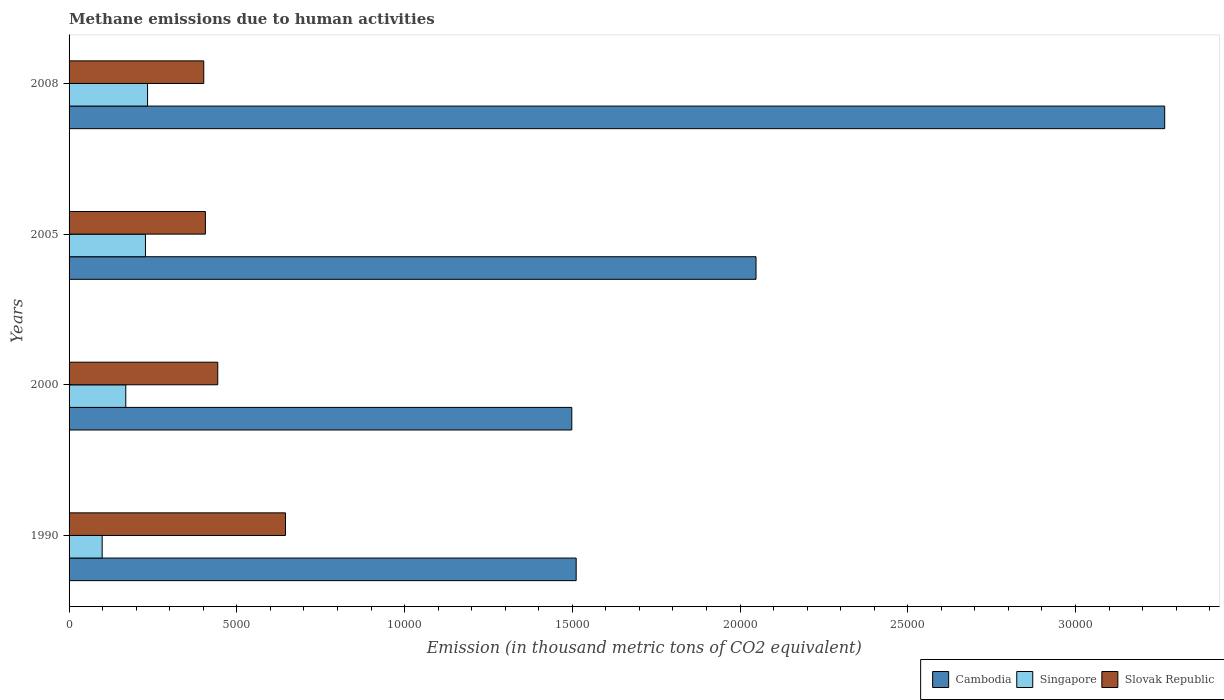How many different coloured bars are there?
Give a very brief answer. 3. How many groups of bars are there?
Provide a succinct answer. 4. Are the number of bars per tick equal to the number of legend labels?
Offer a terse response. Yes. In how many cases, is the number of bars for a given year not equal to the number of legend labels?
Offer a terse response. 0. What is the amount of methane emitted in Cambodia in 1990?
Give a very brief answer. 1.51e+04. Across all years, what is the maximum amount of methane emitted in Cambodia?
Make the answer very short. 3.27e+04. Across all years, what is the minimum amount of methane emitted in Singapore?
Make the answer very short. 986.7. In which year was the amount of methane emitted in Cambodia maximum?
Your answer should be very brief. 2008. In which year was the amount of methane emitted in Slovak Republic minimum?
Provide a succinct answer. 2008. What is the total amount of methane emitted in Cambodia in the graph?
Provide a short and direct response. 8.32e+04. What is the difference between the amount of methane emitted in Singapore in 2000 and that in 2008?
Provide a short and direct response. -649.1. What is the difference between the amount of methane emitted in Cambodia in 1990 and the amount of methane emitted in Singapore in 2005?
Keep it short and to the point. 1.28e+04. What is the average amount of methane emitted in Singapore per year?
Offer a terse response. 1823.45. In the year 1990, what is the difference between the amount of methane emitted in Slovak Republic and amount of methane emitted in Singapore?
Your answer should be very brief. 5464.7. What is the ratio of the amount of methane emitted in Cambodia in 2000 to that in 2008?
Give a very brief answer. 0.46. Is the amount of methane emitted in Singapore in 2000 less than that in 2008?
Provide a short and direct response. Yes. What is the difference between the highest and the second highest amount of methane emitted in Slovak Republic?
Your answer should be very brief. 2019.1. What is the difference between the highest and the lowest amount of methane emitted in Cambodia?
Give a very brief answer. 1.77e+04. What does the 3rd bar from the top in 2005 represents?
Offer a terse response. Cambodia. What does the 3rd bar from the bottom in 2008 represents?
Keep it short and to the point. Slovak Republic. How many years are there in the graph?
Your answer should be very brief. 4. Does the graph contain grids?
Offer a very short reply. No. What is the title of the graph?
Keep it short and to the point. Methane emissions due to human activities. What is the label or title of the X-axis?
Provide a succinct answer. Emission (in thousand metric tons of CO2 equivalent). What is the label or title of the Y-axis?
Give a very brief answer. Years. What is the Emission (in thousand metric tons of CO2 equivalent) in Cambodia in 1990?
Keep it short and to the point. 1.51e+04. What is the Emission (in thousand metric tons of CO2 equivalent) of Singapore in 1990?
Make the answer very short. 986.7. What is the Emission (in thousand metric tons of CO2 equivalent) in Slovak Republic in 1990?
Your answer should be compact. 6451.4. What is the Emission (in thousand metric tons of CO2 equivalent) of Cambodia in 2000?
Provide a succinct answer. 1.50e+04. What is the Emission (in thousand metric tons of CO2 equivalent) in Singapore in 2000?
Your answer should be compact. 1690.6. What is the Emission (in thousand metric tons of CO2 equivalent) of Slovak Republic in 2000?
Your answer should be very brief. 4432.3. What is the Emission (in thousand metric tons of CO2 equivalent) in Cambodia in 2005?
Provide a succinct answer. 2.05e+04. What is the Emission (in thousand metric tons of CO2 equivalent) in Singapore in 2005?
Provide a short and direct response. 2276.8. What is the Emission (in thousand metric tons of CO2 equivalent) in Slovak Republic in 2005?
Make the answer very short. 4063.5. What is the Emission (in thousand metric tons of CO2 equivalent) of Cambodia in 2008?
Your answer should be very brief. 3.27e+04. What is the Emission (in thousand metric tons of CO2 equivalent) of Singapore in 2008?
Ensure brevity in your answer.  2339.7. What is the Emission (in thousand metric tons of CO2 equivalent) in Slovak Republic in 2008?
Give a very brief answer. 4014.6. Across all years, what is the maximum Emission (in thousand metric tons of CO2 equivalent) of Cambodia?
Provide a short and direct response. 3.27e+04. Across all years, what is the maximum Emission (in thousand metric tons of CO2 equivalent) of Singapore?
Give a very brief answer. 2339.7. Across all years, what is the maximum Emission (in thousand metric tons of CO2 equivalent) in Slovak Republic?
Your answer should be very brief. 6451.4. Across all years, what is the minimum Emission (in thousand metric tons of CO2 equivalent) in Cambodia?
Provide a short and direct response. 1.50e+04. Across all years, what is the minimum Emission (in thousand metric tons of CO2 equivalent) in Singapore?
Give a very brief answer. 986.7. Across all years, what is the minimum Emission (in thousand metric tons of CO2 equivalent) in Slovak Republic?
Your response must be concise. 4014.6. What is the total Emission (in thousand metric tons of CO2 equivalent) of Cambodia in the graph?
Offer a terse response. 8.32e+04. What is the total Emission (in thousand metric tons of CO2 equivalent) in Singapore in the graph?
Ensure brevity in your answer.  7293.8. What is the total Emission (in thousand metric tons of CO2 equivalent) in Slovak Republic in the graph?
Make the answer very short. 1.90e+04. What is the difference between the Emission (in thousand metric tons of CO2 equivalent) of Cambodia in 1990 and that in 2000?
Provide a short and direct response. 130.8. What is the difference between the Emission (in thousand metric tons of CO2 equivalent) of Singapore in 1990 and that in 2000?
Ensure brevity in your answer.  -703.9. What is the difference between the Emission (in thousand metric tons of CO2 equivalent) in Slovak Republic in 1990 and that in 2000?
Keep it short and to the point. 2019.1. What is the difference between the Emission (in thousand metric tons of CO2 equivalent) of Cambodia in 1990 and that in 2005?
Offer a very short reply. -5361.1. What is the difference between the Emission (in thousand metric tons of CO2 equivalent) of Singapore in 1990 and that in 2005?
Your response must be concise. -1290.1. What is the difference between the Emission (in thousand metric tons of CO2 equivalent) of Slovak Republic in 1990 and that in 2005?
Make the answer very short. 2387.9. What is the difference between the Emission (in thousand metric tons of CO2 equivalent) of Cambodia in 1990 and that in 2008?
Provide a succinct answer. -1.75e+04. What is the difference between the Emission (in thousand metric tons of CO2 equivalent) in Singapore in 1990 and that in 2008?
Offer a very short reply. -1353. What is the difference between the Emission (in thousand metric tons of CO2 equivalent) in Slovak Republic in 1990 and that in 2008?
Your answer should be compact. 2436.8. What is the difference between the Emission (in thousand metric tons of CO2 equivalent) of Cambodia in 2000 and that in 2005?
Keep it short and to the point. -5491.9. What is the difference between the Emission (in thousand metric tons of CO2 equivalent) in Singapore in 2000 and that in 2005?
Provide a short and direct response. -586.2. What is the difference between the Emission (in thousand metric tons of CO2 equivalent) in Slovak Republic in 2000 and that in 2005?
Ensure brevity in your answer.  368.8. What is the difference between the Emission (in thousand metric tons of CO2 equivalent) of Cambodia in 2000 and that in 2008?
Keep it short and to the point. -1.77e+04. What is the difference between the Emission (in thousand metric tons of CO2 equivalent) in Singapore in 2000 and that in 2008?
Your response must be concise. -649.1. What is the difference between the Emission (in thousand metric tons of CO2 equivalent) in Slovak Republic in 2000 and that in 2008?
Your answer should be compact. 417.7. What is the difference between the Emission (in thousand metric tons of CO2 equivalent) of Cambodia in 2005 and that in 2008?
Make the answer very short. -1.22e+04. What is the difference between the Emission (in thousand metric tons of CO2 equivalent) of Singapore in 2005 and that in 2008?
Your response must be concise. -62.9. What is the difference between the Emission (in thousand metric tons of CO2 equivalent) in Slovak Republic in 2005 and that in 2008?
Give a very brief answer. 48.9. What is the difference between the Emission (in thousand metric tons of CO2 equivalent) of Cambodia in 1990 and the Emission (in thousand metric tons of CO2 equivalent) of Singapore in 2000?
Keep it short and to the point. 1.34e+04. What is the difference between the Emission (in thousand metric tons of CO2 equivalent) in Cambodia in 1990 and the Emission (in thousand metric tons of CO2 equivalent) in Slovak Republic in 2000?
Give a very brief answer. 1.07e+04. What is the difference between the Emission (in thousand metric tons of CO2 equivalent) of Singapore in 1990 and the Emission (in thousand metric tons of CO2 equivalent) of Slovak Republic in 2000?
Make the answer very short. -3445.6. What is the difference between the Emission (in thousand metric tons of CO2 equivalent) in Cambodia in 1990 and the Emission (in thousand metric tons of CO2 equivalent) in Singapore in 2005?
Keep it short and to the point. 1.28e+04. What is the difference between the Emission (in thousand metric tons of CO2 equivalent) of Cambodia in 1990 and the Emission (in thousand metric tons of CO2 equivalent) of Slovak Republic in 2005?
Your answer should be very brief. 1.11e+04. What is the difference between the Emission (in thousand metric tons of CO2 equivalent) of Singapore in 1990 and the Emission (in thousand metric tons of CO2 equivalent) of Slovak Republic in 2005?
Your response must be concise. -3076.8. What is the difference between the Emission (in thousand metric tons of CO2 equivalent) in Cambodia in 1990 and the Emission (in thousand metric tons of CO2 equivalent) in Singapore in 2008?
Keep it short and to the point. 1.28e+04. What is the difference between the Emission (in thousand metric tons of CO2 equivalent) of Cambodia in 1990 and the Emission (in thousand metric tons of CO2 equivalent) of Slovak Republic in 2008?
Offer a terse response. 1.11e+04. What is the difference between the Emission (in thousand metric tons of CO2 equivalent) of Singapore in 1990 and the Emission (in thousand metric tons of CO2 equivalent) of Slovak Republic in 2008?
Ensure brevity in your answer.  -3027.9. What is the difference between the Emission (in thousand metric tons of CO2 equivalent) in Cambodia in 2000 and the Emission (in thousand metric tons of CO2 equivalent) in Singapore in 2005?
Keep it short and to the point. 1.27e+04. What is the difference between the Emission (in thousand metric tons of CO2 equivalent) of Cambodia in 2000 and the Emission (in thousand metric tons of CO2 equivalent) of Slovak Republic in 2005?
Your answer should be very brief. 1.09e+04. What is the difference between the Emission (in thousand metric tons of CO2 equivalent) in Singapore in 2000 and the Emission (in thousand metric tons of CO2 equivalent) in Slovak Republic in 2005?
Ensure brevity in your answer.  -2372.9. What is the difference between the Emission (in thousand metric tons of CO2 equivalent) in Cambodia in 2000 and the Emission (in thousand metric tons of CO2 equivalent) in Singapore in 2008?
Provide a succinct answer. 1.26e+04. What is the difference between the Emission (in thousand metric tons of CO2 equivalent) of Cambodia in 2000 and the Emission (in thousand metric tons of CO2 equivalent) of Slovak Republic in 2008?
Provide a short and direct response. 1.10e+04. What is the difference between the Emission (in thousand metric tons of CO2 equivalent) of Singapore in 2000 and the Emission (in thousand metric tons of CO2 equivalent) of Slovak Republic in 2008?
Make the answer very short. -2324. What is the difference between the Emission (in thousand metric tons of CO2 equivalent) in Cambodia in 2005 and the Emission (in thousand metric tons of CO2 equivalent) in Singapore in 2008?
Ensure brevity in your answer.  1.81e+04. What is the difference between the Emission (in thousand metric tons of CO2 equivalent) of Cambodia in 2005 and the Emission (in thousand metric tons of CO2 equivalent) of Slovak Republic in 2008?
Keep it short and to the point. 1.65e+04. What is the difference between the Emission (in thousand metric tons of CO2 equivalent) of Singapore in 2005 and the Emission (in thousand metric tons of CO2 equivalent) of Slovak Republic in 2008?
Keep it short and to the point. -1737.8. What is the average Emission (in thousand metric tons of CO2 equivalent) in Cambodia per year?
Provide a succinct answer. 2.08e+04. What is the average Emission (in thousand metric tons of CO2 equivalent) in Singapore per year?
Offer a terse response. 1823.45. What is the average Emission (in thousand metric tons of CO2 equivalent) of Slovak Republic per year?
Offer a terse response. 4740.45. In the year 1990, what is the difference between the Emission (in thousand metric tons of CO2 equivalent) in Cambodia and Emission (in thousand metric tons of CO2 equivalent) in Singapore?
Give a very brief answer. 1.41e+04. In the year 1990, what is the difference between the Emission (in thousand metric tons of CO2 equivalent) of Cambodia and Emission (in thousand metric tons of CO2 equivalent) of Slovak Republic?
Keep it short and to the point. 8664.3. In the year 1990, what is the difference between the Emission (in thousand metric tons of CO2 equivalent) in Singapore and Emission (in thousand metric tons of CO2 equivalent) in Slovak Republic?
Provide a short and direct response. -5464.7. In the year 2000, what is the difference between the Emission (in thousand metric tons of CO2 equivalent) of Cambodia and Emission (in thousand metric tons of CO2 equivalent) of Singapore?
Your answer should be very brief. 1.33e+04. In the year 2000, what is the difference between the Emission (in thousand metric tons of CO2 equivalent) of Cambodia and Emission (in thousand metric tons of CO2 equivalent) of Slovak Republic?
Keep it short and to the point. 1.06e+04. In the year 2000, what is the difference between the Emission (in thousand metric tons of CO2 equivalent) in Singapore and Emission (in thousand metric tons of CO2 equivalent) in Slovak Republic?
Your response must be concise. -2741.7. In the year 2005, what is the difference between the Emission (in thousand metric tons of CO2 equivalent) in Cambodia and Emission (in thousand metric tons of CO2 equivalent) in Singapore?
Offer a very short reply. 1.82e+04. In the year 2005, what is the difference between the Emission (in thousand metric tons of CO2 equivalent) in Cambodia and Emission (in thousand metric tons of CO2 equivalent) in Slovak Republic?
Give a very brief answer. 1.64e+04. In the year 2005, what is the difference between the Emission (in thousand metric tons of CO2 equivalent) in Singapore and Emission (in thousand metric tons of CO2 equivalent) in Slovak Republic?
Provide a short and direct response. -1786.7. In the year 2008, what is the difference between the Emission (in thousand metric tons of CO2 equivalent) of Cambodia and Emission (in thousand metric tons of CO2 equivalent) of Singapore?
Your answer should be very brief. 3.03e+04. In the year 2008, what is the difference between the Emission (in thousand metric tons of CO2 equivalent) of Cambodia and Emission (in thousand metric tons of CO2 equivalent) of Slovak Republic?
Ensure brevity in your answer.  2.86e+04. In the year 2008, what is the difference between the Emission (in thousand metric tons of CO2 equivalent) in Singapore and Emission (in thousand metric tons of CO2 equivalent) in Slovak Republic?
Offer a terse response. -1674.9. What is the ratio of the Emission (in thousand metric tons of CO2 equivalent) in Cambodia in 1990 to that in 2000?
Ensure brevity in your answer.  1.01. What is the ratio of the Emission (in thousand metric tons of CO2 equivalent) of Singapore in 1990 to that in 2000?
Keep it short and to the point. 0.58. What is the ratio of the Emission (in thousand metric tons of CO2 equivalent) in Slovak Republic in 1990 to that in 2000?
Make the answer very short. 1.46. What is the ratio of the Emission (in thousand metric tons of CO2 equivalent) in Cambodia in 1990 to that in 2005?
Offer a terse response. 0.74. What is the ratio of the Emission (in thousand metric tons of CO2 equivalent) in Singapore in 1990 to that in 2005?
Your answer should be compact. 0.43. What is the ratio of the Emission (in thousand metric tons of CO2 equivalent) of Slovak Republic in 1990 to that in 2005?
Your answer should be compact. 1.59. What is the ratio of the Emission (in thousand metric tons of CO2 equivalent) of Cambodia in 1990 to that in 2008?
Your response must be concise. 0.46. What is the ratio of the Emission (in thousand metric tons of CO2 equivalent) of Singapore in 1990 to that in 2008?
Make the answer very short. 0.42. What is the ratio of the Emission (in thousand metric tons of CO2 equivalent) of Slovak Republic in 1990 to that in 2008?
Ensure brevity in your answer.  1.61. What is the ratio of the Emission (in thousand metric tons of CO2 equivalent) in Cambodia in 2000 to that in 2005?
Your answer should be very brief. 0.73. What is the ratio of the Emission (in thousand metric tons of CO2 equivalent) in Singapore in 2000 to that in 2005?
Offer a very short reply. 0.74. What is the ratio of the Emission (in thousand metric tons of CO2 equivalent) of Slovak Republic in 2000 to that in 2005?
Your answer should be compact. 1.09. What is the ratio of the Emission (in thousand metric tons of CO2 equivalent) of Cambodia in 2000 to that in 2008?
Offer a terse response. 0.46. What is the ratio of the Emission (in thousand metric tons of CO2 equivalent) of Singapore in 2000 to that in 2008?
Offer a terse response. 0.72. What is the ratio of the Emission (in thousand metric tons of CO2 equivalent) in Slovak Republic in 2000 to that in 2008?
Provide a succinct answer. 1.1. What is the ratio of the Emission (in thousand metric tons of CO2 equivalent) in Cambodia in 2005 to that in 2008?
Your response must be concise. 0.63. What is the ratio of the Emission (in thousand metric tons of CO2 equivalent) in Singapore in 2005 to that in 2008?
Your answer should be compact. 0.97. What is the ratio of the Emission (in thousand metric tons of CO2 equivalent) of Slovak Republic in 2005 to that in 2008?
Provide a short and direct response. 1.01. What is the difference between the highest and the second highest Emission (in thousand metric tons of CO2 equivalent) of Cambodia?
Your response must be concise. 1.22e+04. What is the difference between the highest and the second highest Emission (in thousand metric tons of CO2 equivalent) in Singapore?
Make the answer very short. 62.9. What is the difference between the highest and the second highest Emission (in thousand metric tons of CO2 equivalent) of Slovak Republic?
Offer a very short reply. 2019.1. What is the difference between the highest and the lowest Emission (in thousand metric tons of CO2 equivalent) in Cambodia?
Give a very brief answer. 1.77e+04. What is the difference between the highest and the lowest Emission (in thousand metric tons of CO2 equivalent) in Singapore?
Your answer should be compact. 1353. What is the difference between the highest and the lowest Emission (in thousand metric tons of CO2 equivalent) of Slovak Republic?
Give a very brief answer. 2436.8. 